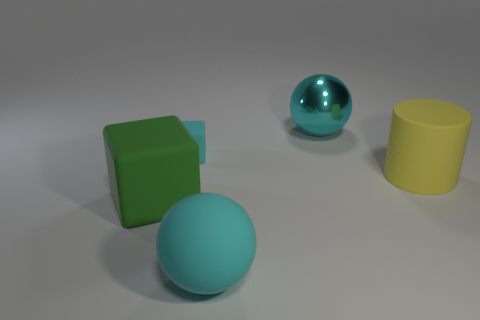Add 5 tiny purple shiny spheres. How many objects exist? 10 Subtract all green cubes. How many cubes are left? 1 Subtract 0 gray spheres. How many objects are left? 5 Subtract all balls. How many objects are left? 3 Subtract 1 cylinders. How many cylinders are left? 0 Subtract all yellow blocks. Subtract all blue spheres. How many blocks are left? 2 Subtract all red balls. How many cyan blocks are left? 1 Subtract all green cubes. Subtract all blocks. How many objects are left? 2 Add 2 big yellow rubber things. How many big yellow rubber things are left? 3 Add 1 large brown cubes. How many large brown cubes exist? 1 